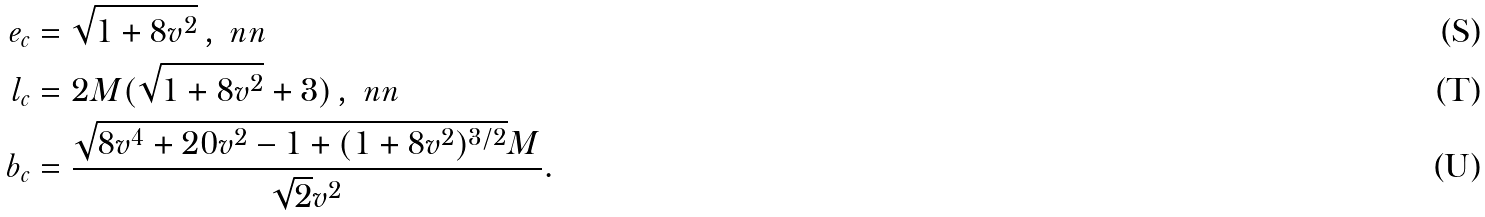<formula> <loc_0><loc_0><loc_500><loc_500>e _ { c } & = \sqrt { 1 + 8 v ^ { 2 } } \, , \ n n \\ l _ { c } & = 2 M ( \sqrt { 1 + 8 v ^ { 2 } } + 3 ) \, , \ n n \\ b _ { c } & = \frac { \sqrt { 8 v ^ { 4 } + 2 0 v ^ { 2 } - 1 + ( 1 + 8 v ^ { 2 } ) ^ { 3 / 2 } } M } { \sqrt { 2 } v ^ { 2 } } .</formula> 